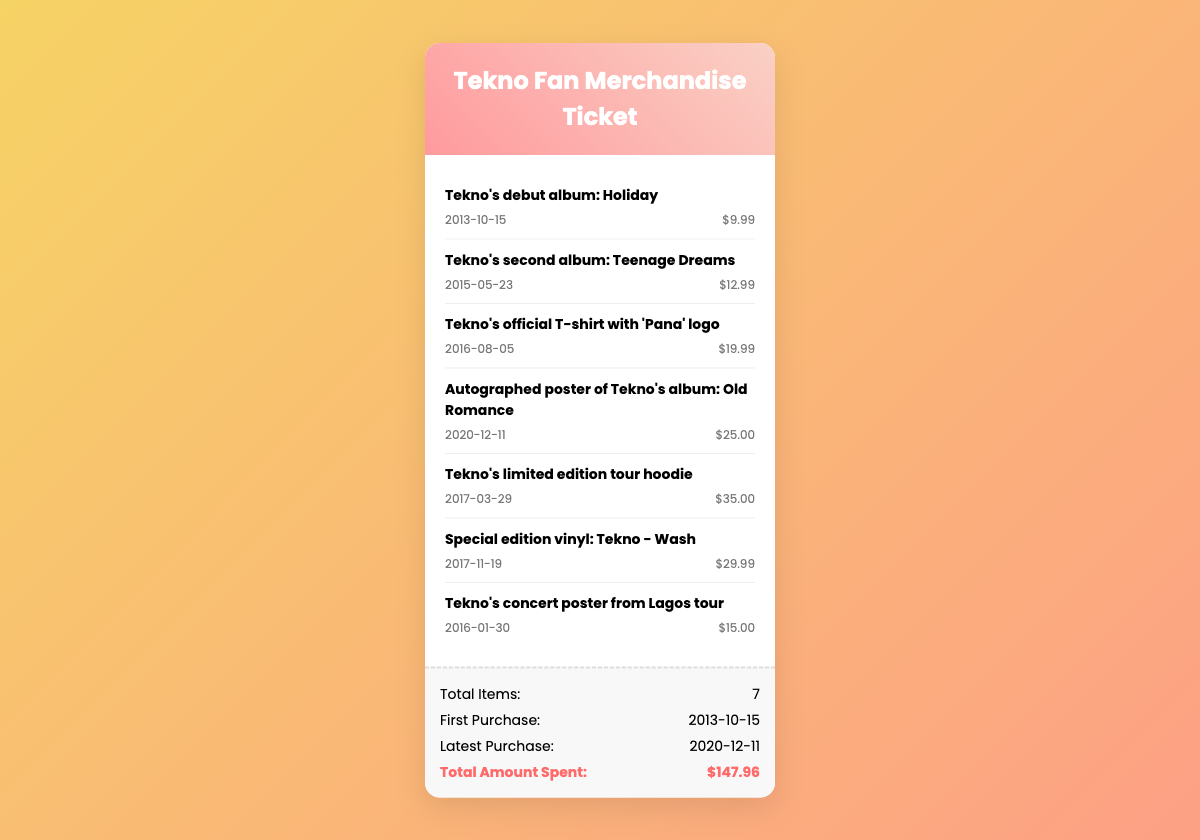What is the title of Tekno's first album? The first album listed is "Holiday," which was released in 2013.
Answer: Holiday When was the latest purchase made? The most recent purchase date is provided in the summary section of the document.
Answer: 2020-12-11 How much did the special edition vinyl cost? The price is specified next to the item name in the merchandise list.
Answer: $29.99 What is the total amount spent on merchandise? The total amount is given in the summary section of the document.
Answer: $147.96 How many items are listed in the merchandise purchase history? The total number of items is stated in the summary section.
Answer: 7 What date was the autographed poster purchased? The purchase date is included in the item details of the merchandise list.
Answer: 2020-12-11 What is the price of Tekno's official T-shirt? The price is clearly listed next to the item name in the merchandise list.
Answer: $19.99 What is the name of the merchandise item purchased on 2016-01-30? The item corresponding to that purchase date is specified in the list.
Answer: Tekno's concert poster from Lagos tour What limited edition item was bought on 2017-03-29? The item name is provided in the merchandise list corresponding to that date.
Answer: Tekno's limited edition tour hoodie 